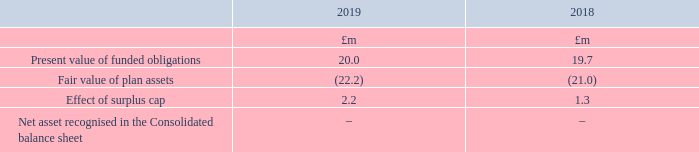Amounts recognised in the balance sheet are as follows:
The surplus of £2.2m (2018: £1.3m) has not been recognised as an asset as it is not deemed to be recoverable by the Group.
What has not been recognised as an asset in 2019? Surplus of £2.2m. Why is the surplus not recognised as an asset? As it is not deemed to be recoverable by the group. What are the components considered under the Net asset recognised in the Consolidated balance sheet? Present value of funded obligations, fair value of plan assets, effect of surplus cap. In which year was the Effect of surplus cap larger? 2.2>1.3
Answer: 2019. What was the change in effect of surplus cap in 2019 from 2018?
Answer scale should be: million. 2.2-1.3
Answer: 0.9. What was the percentage change in effect of surplus cap in 2019 from 2018?
Answer scale should be: percent. (2.2-1.3)/1.3
Answer: 69.23. 